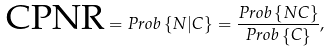<formula> <loc_0><loc_0><loc_500><loc_500>\text {CPNR} = P r o b \left \{ N | C \right \} = \frac { P r o b \left \{ N C \right \} } { P r o b \left \{ C \right \} } ,</formula> 